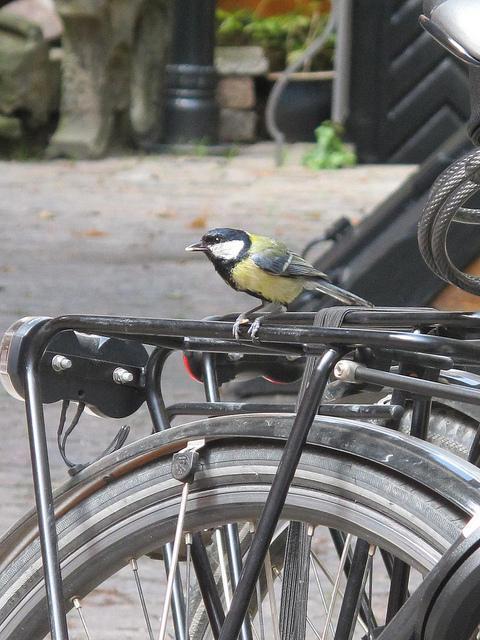Verify the accuracy of this image caption: "The bicycle is beneath the bird.".
Answer yes or no. Yes. 